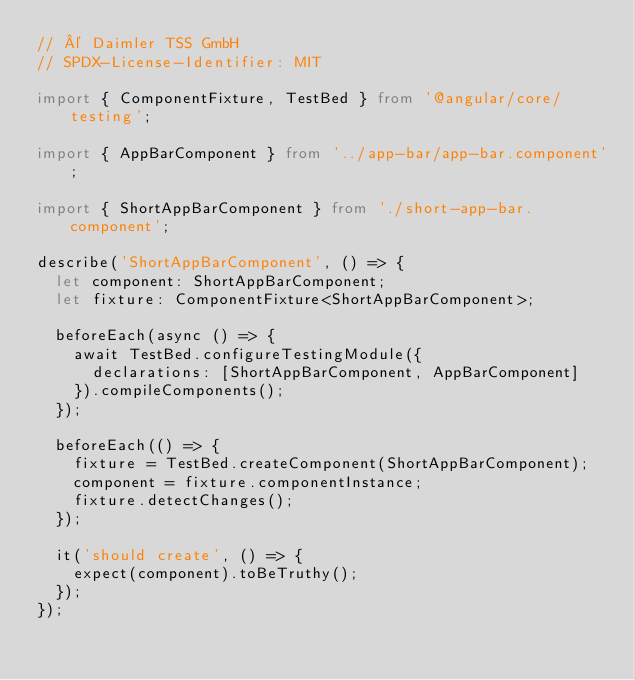<code> <loc_0><loc_0><loc_500><loc_500><_TypeScript_>// © Daimler TSS GmbH
// SPDX-License-Identifier: MIT

import { ComponentFixture, TestBed } from '@angular/core/testing';

import { AppBarComponent } from '../app-bar/app-bar.component';

import { ShortAppBarComponent } from './short-app-bar.component';

describe('ShortAppBarComponent', () => {
  let component: ShortAppBarComponent;
  let fixture: ComponentFixture<ShortAppBarComponent>;

  beforeEach(async () => {
    await TestBed.configureTestingModule({
      declarations: [ShortAppBarComponent, AppBarComponent]
    }).compileComponents();
  });

  beforeEach(() => {
    fixture = TestBed.createComponent(ShortAppBarComponent);
    component = fixture.componentInstance;
    fixture.detectChanges();
  });

  it('should create', () => {
    expect(component).toBeTruthy();
  });
});
</code> 